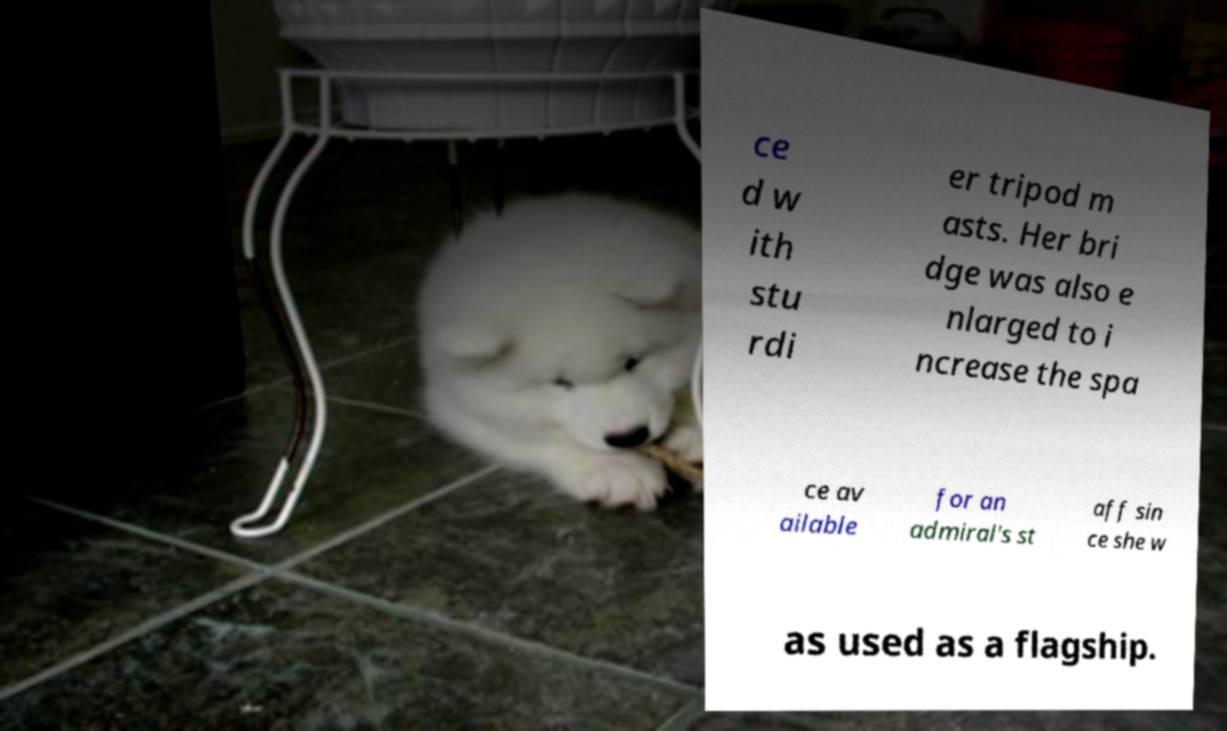Can you accurately transcribe the text from the provided image for me? ce d w ith stu rdi er tripod m asts. Her bri dge was also e nlarged to i ncrease the spa ce av ailable for an admiral's st aff sin ce she w as used as a flagship. 